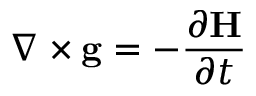<formula> <loc_0><loc_0><loc_500><loc_500>\nabla \times g = - { \frac { \partial H } { \partial t } } \,</formula> 